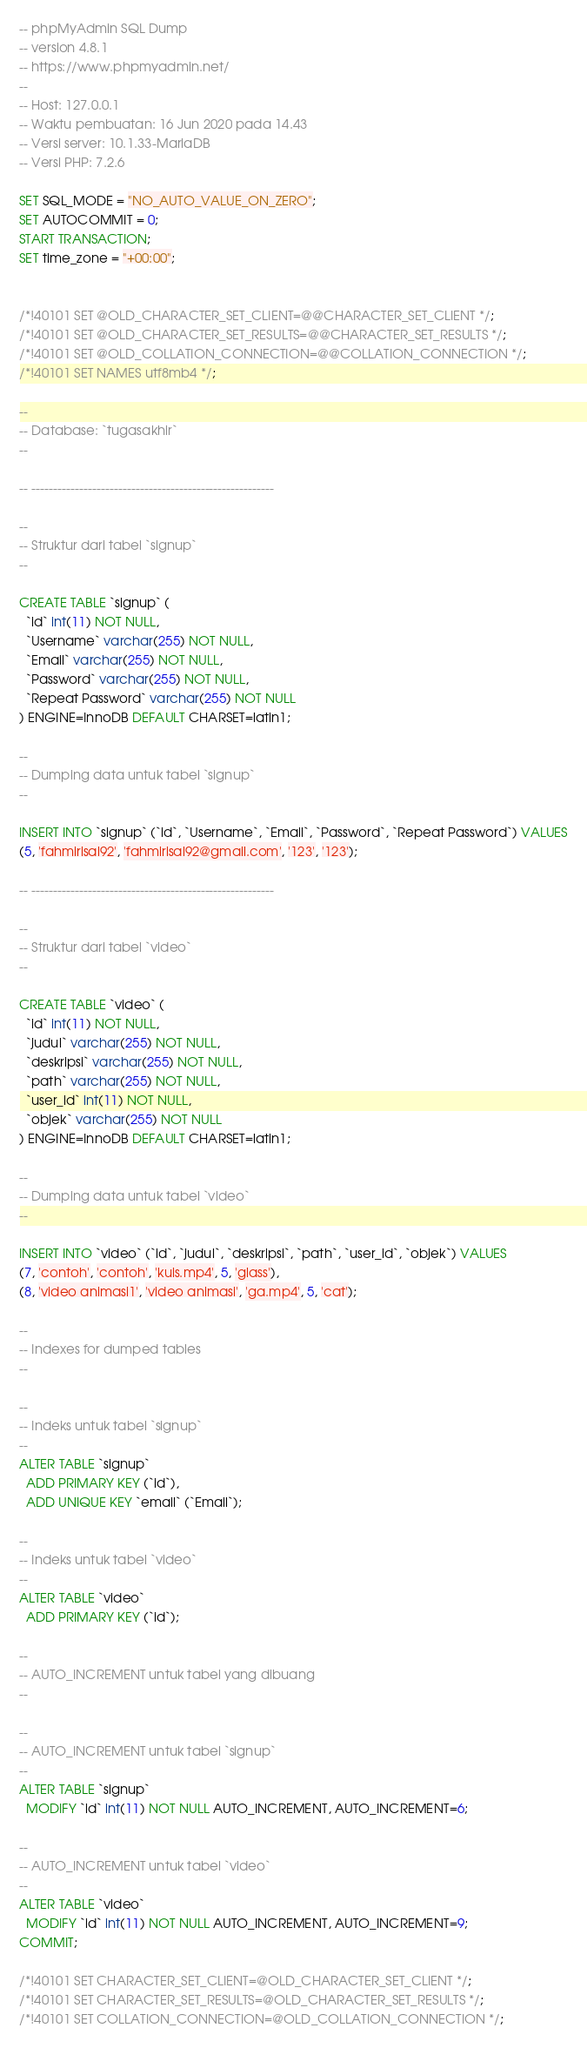<code> <loc_0><loc_0><loc_500><loc_500><_SQL_>-- phpMyAdmin SQL Dump
-- version 4.8.1
-- https://www.phpmyadmin.net/
--
-- Host: 127.0.0.1
-- Waktu pembuatan: 16 Jun 2020 pada 14.43
-- Versi server: 10.1.33-MariaDB
-- Versi PHP: 7.2.6

SET SQL_MODE = "NO_AUTO_VALUE_ON_ZERO";
SET AUTOCOMMIT = 0;
START TRANSACTION;
SET time_zone = "+00:00";


/*!40101 SET @OLD_CHARACTER_SET_CLIENT=@@CHARACTER_SET_CLIENT */;
/*!40101 SET @OLD_CHARACTER_SET_RESULTS=@@CHARACTER_SET_RESULTS */;
/*!40101 SET @OLD_COLLATION_CONNECTION=@@COLLATION_CONNECTION */;
/*!40101 SET NAMES utf8mb4 */;

--
-- Database: `tugasakhir`
--

-- --------------------------------------------------------

--
-- Struktur dari tabel `signup`
--

CREATE TABLE `signup` (
  `id` int(11) NOT NULL,
  `Username` varchar(255) NOT NULL,
  `Email` varchar(255) NOT NULL,
  `Password` varchar(255) NOT NULL,
  `Repeat Password` varchar(255) NOT NULL
) ENGINE=InnoDB DEFAULT CHARSET=latin1;

--
-- Dumping data untuk tabel `signup`
--

INSERT INTO `signup` (`id`, `Username`, `Email`, `Password`, `Repeat Password`) VALUES
(5, 'fahmirisal92', 'fahmirisal92@gmail.com', '123', '123');

-- --------------------------------------------------------

--
-- Struktur dari tabel `video`
--

CREATE TABLE `video` (
  `id` int(11) NOT NULL,
  `judul` varchar(255) NOT NULL,
  `deskripsi` varchar(255) NOT NULL,
  `path` varchar(255) NOT NULL,
  `user_id` int(11) NOT NULL,
  `objek` varchar(255) NOT NULL
) ENGINE=InnoDB DEFAULT CHARSET=latin1;

--
-- Dumping data untuk tabel `video`
--

INSERT INTO `video` (`id`, `judul`, `deskripsi`, `path`, `user_id`, `objek`) VALUES
(7, 'contoh', 'contoh', 'kuis.mp4', 5, 'glass'),
(8, 'video animasi1', 'video animasi', 'ga.mp4', 5, 'cat');

--
-- Indexes for dumped tables
--

--
-- Indeks untuk tabel `signup`
--
ALTER TABLE `signup`
  ADD PRIMARY KEY (`id`),
  ADD UNIQUE KEY `email` (`Email`);

--
-- Indeks untuk tabel `video`
--
ALTER TABLE `video`
  ADD PRIMARY KEY (`id`);

--
-- AUTO_INCREMENT untuk tabel yang dibuang
--

--
-- AUTO_INCREMENT untuk tabel `signup`
--
ALTER TABLE `signup`
  MODIFY `id` int(11) NOT NULL AUTO_INCREMENT, AUTO_INCREMENT=6;

--
-- AUTO_INCREMENT untuk tabel `video`
--
ALTER TABLE `video`
  MODIFY `id` int(11) NOT NULL AUTO_INCREMENT, AUTO_INCREMENT=9;
COMMIT;

/*!40101 SET CHARACTER_SET_CLIENT=@OLD_CHARACTER_SET_CLIENT */;
/*!40101 SET CHARACTER_SET_RESULTS=@OLD_CHARACTER_SET_RESULTS */;
/*!40101 SET COLLATION_CONNECTION=@OLD_COLLATION_CONNECTION */;
</code> 